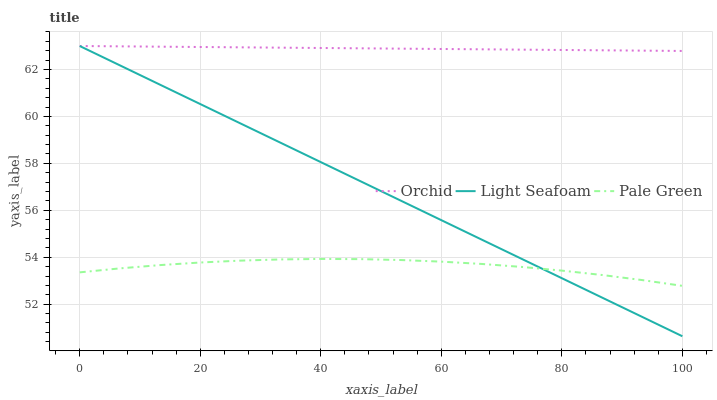Does Light Seafoam have the minimum area under the curve?
Answer yes or no. No. Does Light Seafoam have the maximum area under the curve?
Answer yes or no. No. Is Light Seafoam the smoothest?
Answer yes or no. No. Is Light Seafoam the roughest?
Answer yes or no. No. Does Orchid have the lowest value?
Answer yes or no. No. Is Pale Green less than Orchid?
Answer yes or no. Yes. Is Orchid greater than Pale Green?
Answer yes or no. Yes. Does Pale Green intersect Orchid?
Answer yes or no. No. 